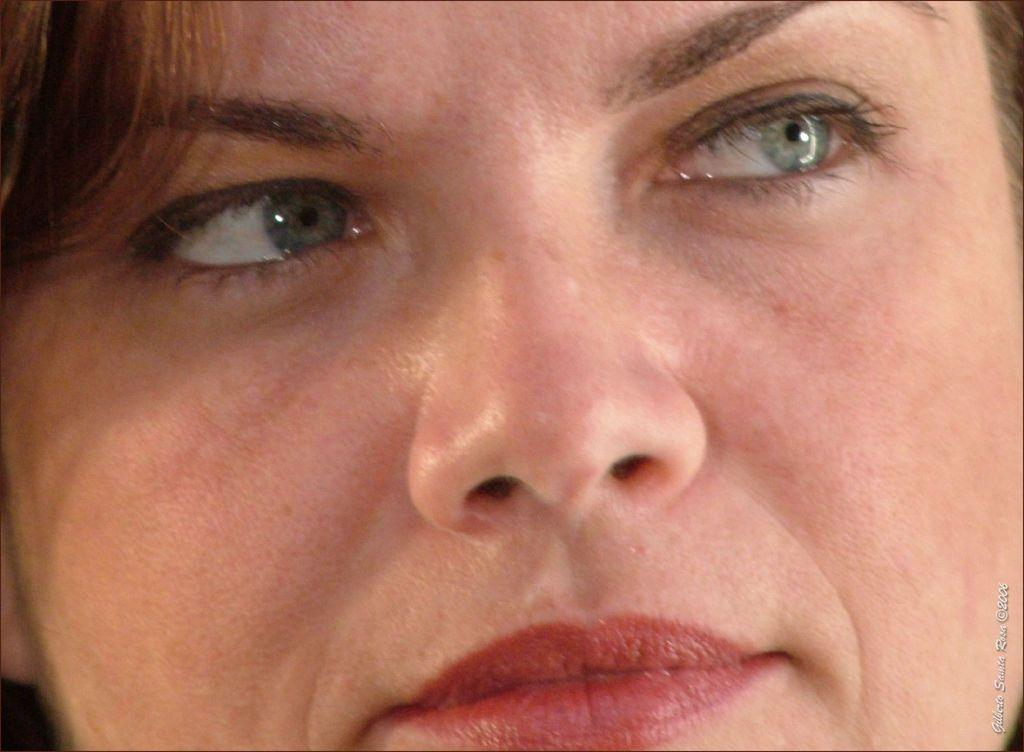What is the main subject of the image? The main subject of the image is a person's face. Can you describe anything else present in the image besides the person's face? Yes, there is text on the right side of the image. What type of pet is visible in the image? There is no pet present in the image; it features a person's face and text. What degree does the person in the image hold? The provided facts do not mention any information about the person's degree or qualifications. 